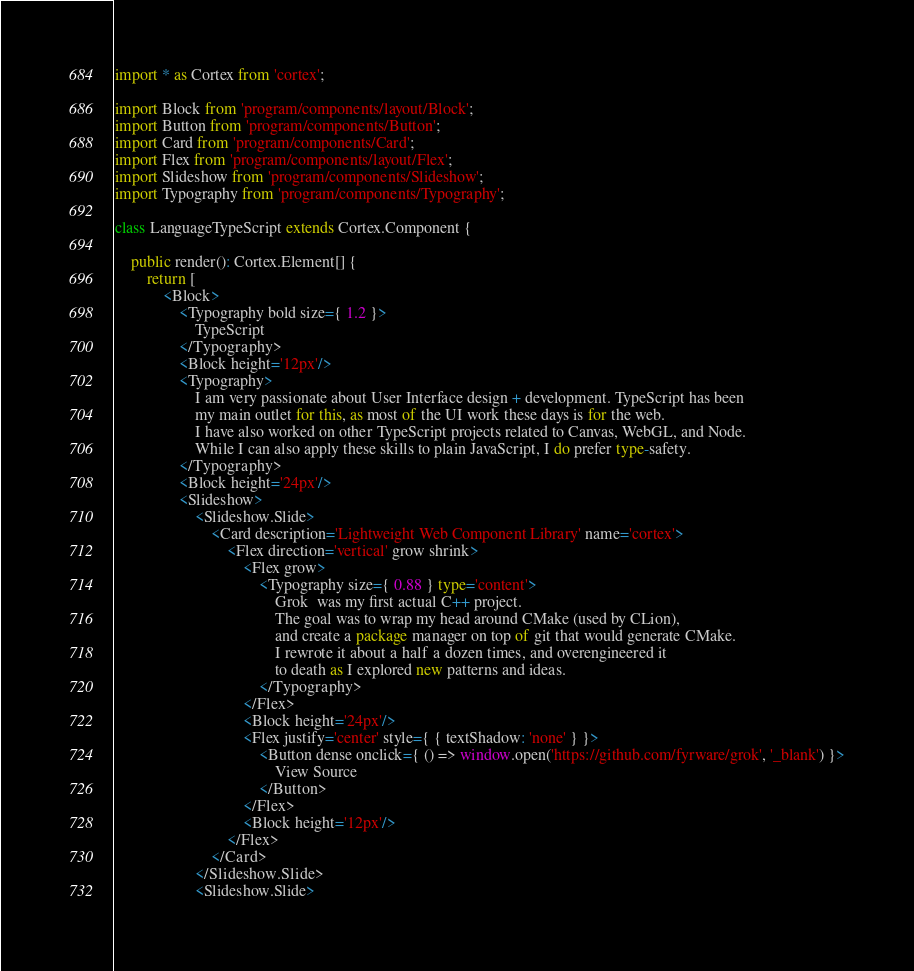<code> <loc_0><loc_0><loc_500><loc_500><_TypeScript_>import * as Cortex from 'cortex';

import Block from 'program/components/layout/Block';
import Button from 'program/components/Button';
import Card from 'program/components/Card';
import Flex from 'program/components/layout/Flex';
import Slideshow from 'program/components/Slideshow';
import Typography from 'program/components/Typography';

class LanguageTypeScript extends Cortex.Component {

    public render(): Cortex.Element[] {
        return [
            <Block>
                <Typography bold size={ 1.2 }>
                    TypeScript
                </Typography>
                <Block height='12px'/>
                <Typography>
                    I am very passionate about User Interface design + development. TypeScript has been
                    my main outlet for this, as most of the UI work these days is for the web.
                    I have also worked on other TypeScript projects related to Canvas, WebGL, and Node.
                    While I can also apply these skills to plain JavaScript, I do prefer type-safety.
                </Typography>
                <Block height='24px'/>
                <Slideshow>
                    <Slideshow.Slide>
                        <Card description='Lightweight Web Component Library' name='cortex'>
                            <Flex direction='vertical' grow shrink>
                                <Flex grow>
                                    <Typography size={ 0.88 } type='content'>
                                        Grok  was my first actual C++ project.
                                        The goal was to wrap my head around CMake (used by CLion),
                                        and create a package manager on top of git that would generate CMake.
                                        I rewrote it about a half a dozen times, and overengineered it
                                        to death as I explored new patterns and ideas.
                                    </Typography>
                                </Flex>
                                <Block height='24px'/>
                                <Flex justify='center' style={ { textShadow: 'none' } }>
                                    <Button dense onclick={ () => window.open('https://github.com/fyrware/grok', '_blank') }>
                                        View Source
                                    </Button>
                                </Flex>
                                <Block height='12px'/>
                            </Flex>
                        </Card>
                    </Slideshow.Slide>
                    <Slideshow.Slide></code> 